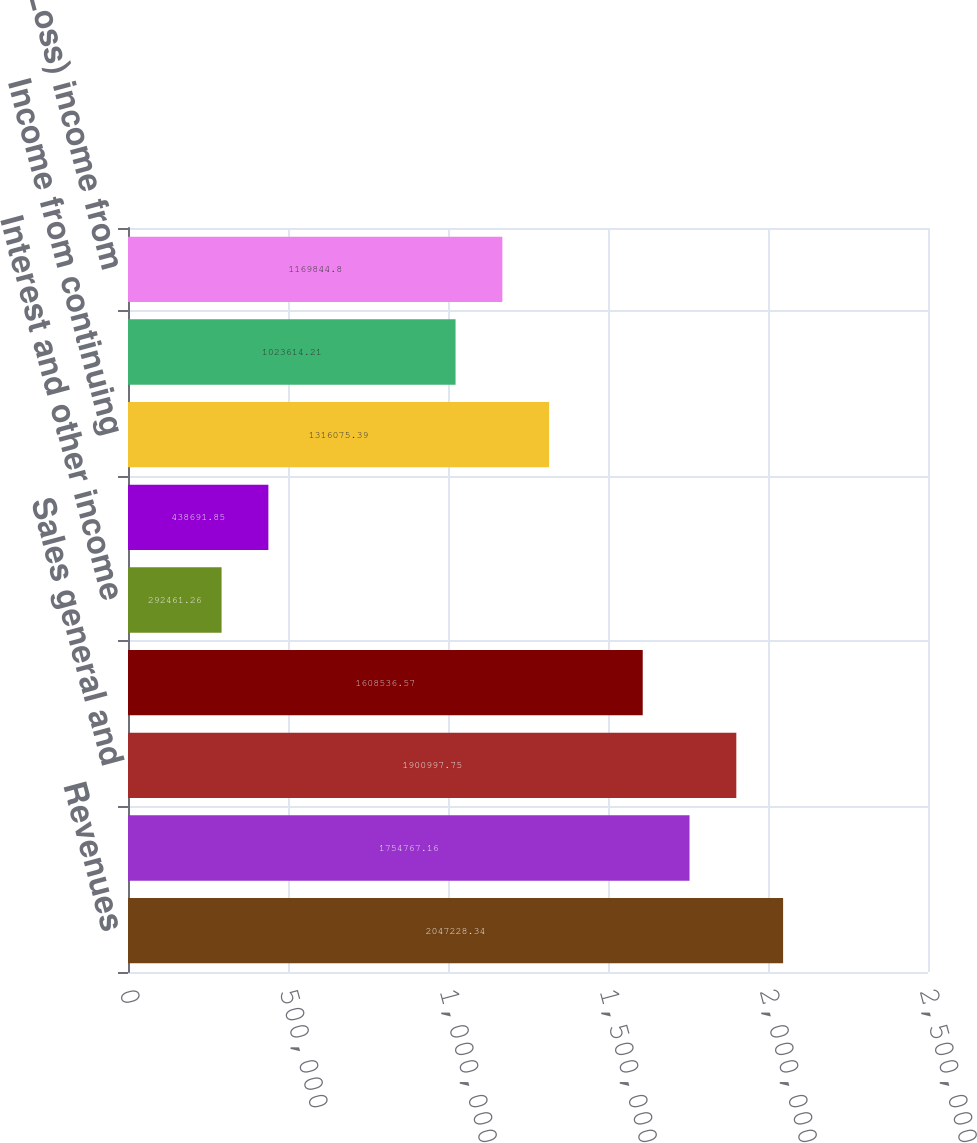Convert chart to OTSL. <chart><loc_0><loc_0><loc_500><loc_500><bar_chart><fcel>Revenues<fcel>Cost of service<fcel>Sales general and<fcel>Operating income<fcel>Interest and other income<fcel>Interest and other expense<fcel>Income from continuing<fcel>Provision for income taxes<fcel>(Loss) income from<nl><fcel>2.04723e+06<fcel>1.75477e+06<fcel>1.901e+06<fcel>1.60854e+06<fcel>292461<fcel>438692<fcel>1.31608e+06<fcel>1.02361e+06<fcel>1.16984e+06<nl></chart> 